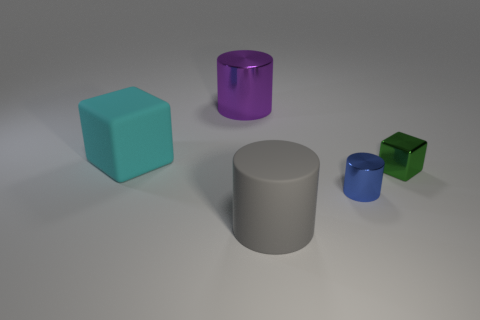How many other things are the same material as the big block?
Make the answer very short. 1. What is the tiny green object made of?
Ensure brevity in your answer.  Metal. There is a small metal object that is behind the tiny blue metal cylinder; is it the same color as the object to the left of the purple thing?
Offer a very short reply. No. Is the number of big cylinders that are in front of the big cyan matte block greater than the number of large brown matte spheres?
Provide a short and direct response. Yes. Does the cube that is on the left side of the green metallic block have the same size as the tiny metal cube?
Your answer should be very brief. No. Are there any other gray matte cylinders that have the same size as the gray rubber cylinder?
Your answer should be compact. No. There is a big cylinder behind the tiny green metallic cube; what color is it?
Offer a terse response. Purple. What shape is the metal object that is both to the left of the small shiny cube and on the right side of the purple object?
Keep it short and to the point. Cylinder. How many other shiny things have the same shape as the purple thing?
Provide a succinct answer. 1. What number of tiny blue shiny things are there?
Offer a very short reply. 1. 